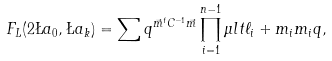<formula> <loc_0><loc_0><loc_500><loc_500>F _ { L } ( 2 \L a _ { 0 } , \L a _ { k } ) = \sum q ^ { \vec { m } ^ { t } C ^ { - 1 } \vec { m } } \prod _ { i = 1 } ^ { n - 1 } \mu l t { \ell _ { i } + m _ { i } } { m _ { i } } { q } ,</formula> 